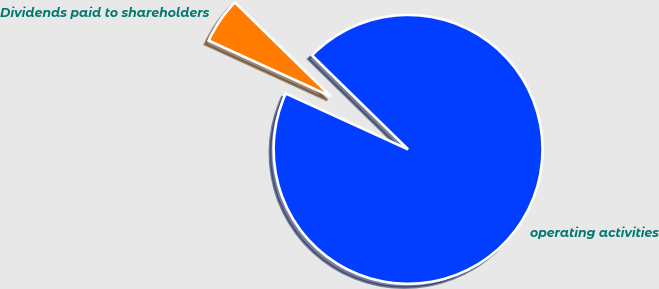<chart> <loc_0><loc_0><loc_500><loc_500><pie_chart><fcel>operating activities<fcel>Dividends paid to shareholders<nl><fcel>94.49%<fcel>5.51%<nl></chart> 